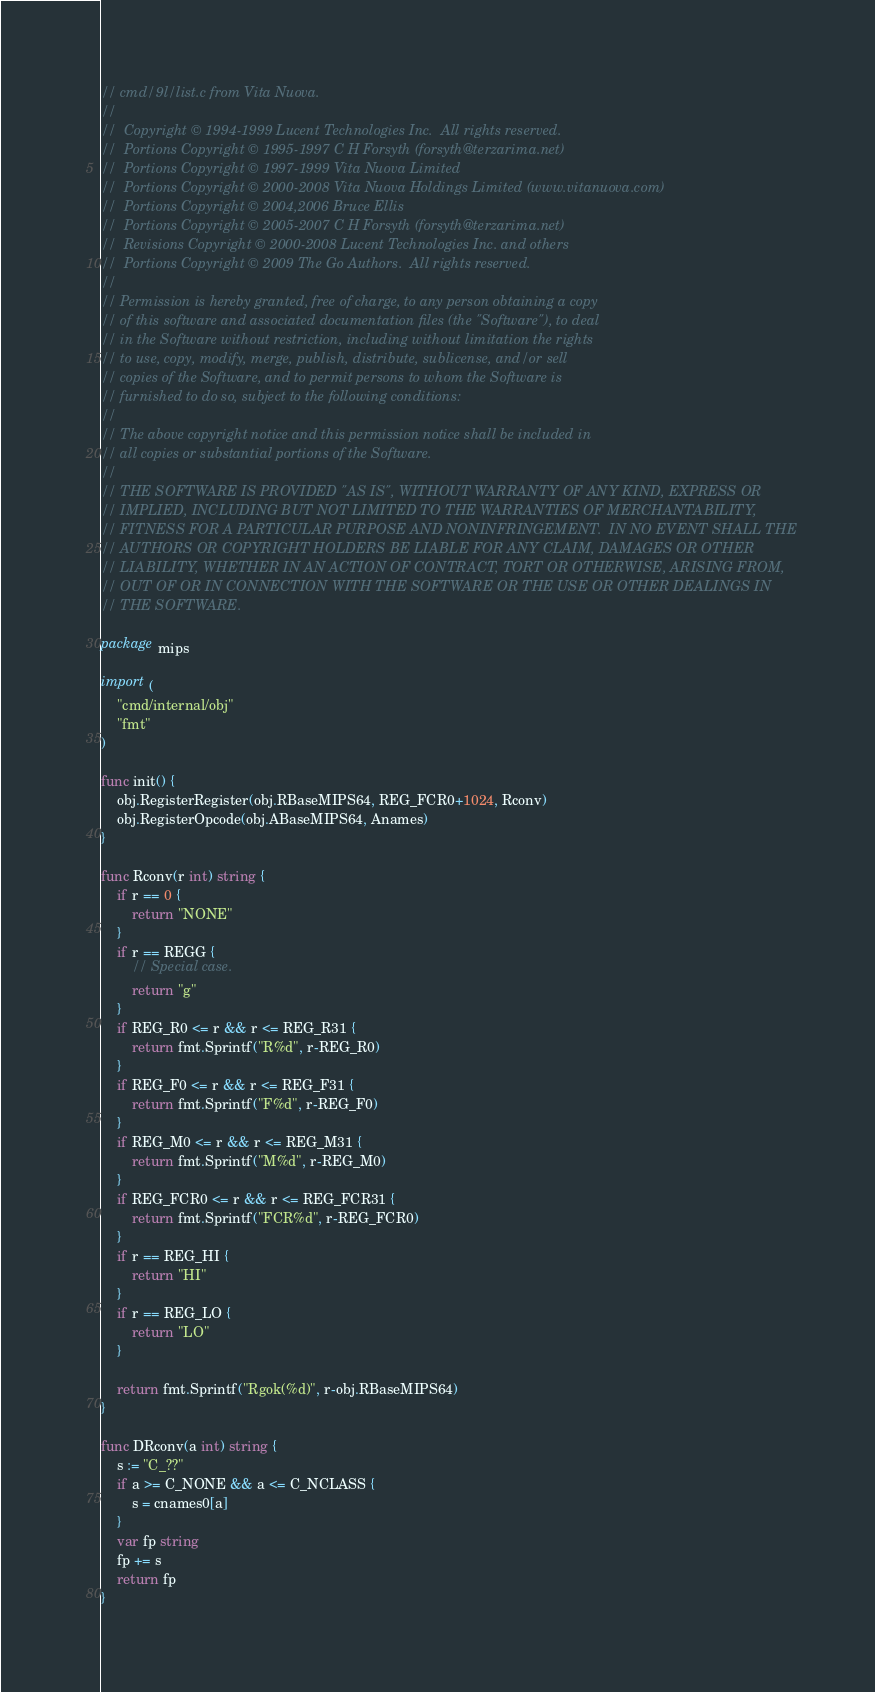Convert code to text. <code><loc_0><loc_0><loc_500><loc_500><_Go_>// cmd/9l/list.c from Vita Nuova.
//
//	Copyright © 1994-1999 Lucent Technologies Inc.  All rights reserved.
//	Portions Copyright © 1995-1997 C H Forsyth (forsyth@terzarima.net)
//	Portions Copyright © 1997-1999 Vita Nuova Limited
//	Portions Copyright © 2000-2008 Vita Nuova Holdings Limited (www.vitanuova.com)
//	Portions Copyright © 2004,2006 Bruce Ellis
//	Portions Copyright © 2005-2007 C H Forsyth (forsyth@terzarima.net)
//	Revisions Copyright © 2000-2008 Lucent Technologies Inc. and others
//	Portions Copyright © 2009 The Go Authors.  All rights reserved.
//
// Permission is hereby granted, free of charge, to any person obtaining a copy
// of this software and associated documentation files (the "Software"), to deal
// in the Software without restriction, including without limitation the rights
// to use, copy, modify, merge, publish, distribute, sublicense, and/or sell
// copies of the Software, and to permit persons to whom the Software is
// furnished to do so, subject to the following conditions:
//
// The above copyright notice and this permission notice shall be included in
// all copies or substantial portions of the Software.
//
// THE SOFTWARE IS PROVIDED "AS IS", WITHOUT WARRANTY OF ANY KIND, EXPRESS OR
// IMPLIED, INCLUDING BUT NOT LIMITED TO THE WARRANTIES OF MERCHANTABILITY,
// FITNESS FOR A PARTICULAR PURPOSE AND NONINFRINGEMENT.  IN NO EVENT SHALL THE
// AUTHORS OR COPYRIGHT HOLDERS BE LIABLE FOR ANY CLAIM, DAMAGES OR OTHER
// LIABILITY, WHETHER IN AN ACTION OF CONTRACT, TORT OR OTHERWISE, ARISING FROM,
// OUT OF OR IN CONNECTION WITH THE SOFTWARE OR THE USE OR OTHER DEALINGS IN
// THE SOFTWARE.

package mips

import (
	"cmd/internal/obj"
	"fmt"
)

func init() {
	obj.RegisterRegister(obj.RBaseMIPS64, REG_FCR0+1024, Rconv)
	obj.RegisterOpcode(obj.ABaseMIPS64, Anames)
}

func Rconv(r int) string {
	if r == 0 {
		return "NONE"
	}
	if r == REGG {
		// Special case.
		return "g"
	}
	if REG_R0 <= r && r <= REG_R31 {
		return fmt.Sprintf("R%d", r-REG_R0)
	}
	if REG_F0 <= r && r <= REG_F31 {
		return fmt.Sprintf("F%d", r-REG_F0)
	}
	if REG_M0 <= r && r <= REG_M31 {
		return fmt.Sprintf("M%d", r-REG_M0)
	}
	if REG_FCR0 <= r && r <= REG_FCR31 {
		return fmt.Sprintf("FCR%d", r-REG_FCR0)
	}
	if r == REG_HI {
		return "HI"
	}
	if r == REG_LO {
		return "LO"
	}

	return fmt.Sprintf("Rgok(%d)", r-obj.RBaseMIPS64)
}

func DRconv(a int) string {
	s := "C_??"
	if a >= C_NONE && a <= C_NCLASS {
		s = cnames0[a]
	}
	var fp string
	fp += s
	return fp
}
</code> 